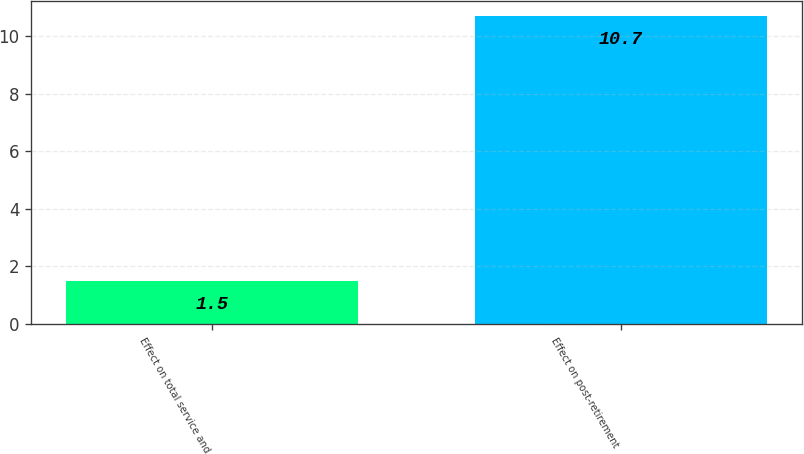Convert chart. <chart><loc_0><loc_0><loc_500><loc_500><bar_chart><fcel>Effect on total service and<fcel>Effect on post-retirement<nl><fcel>1.5<fcel>10.7<nl></chart> 